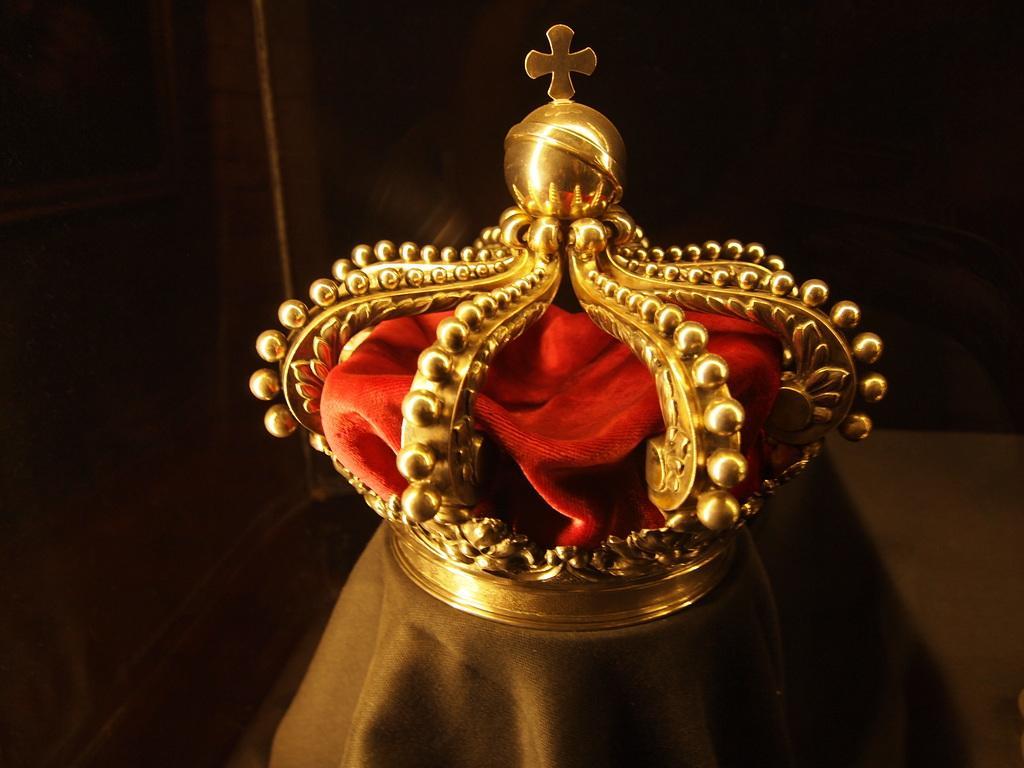How would you summarize this image in a sentence or two? In this picture we can see a golden crown and a red cloth on a platform and in the background it is dark. 